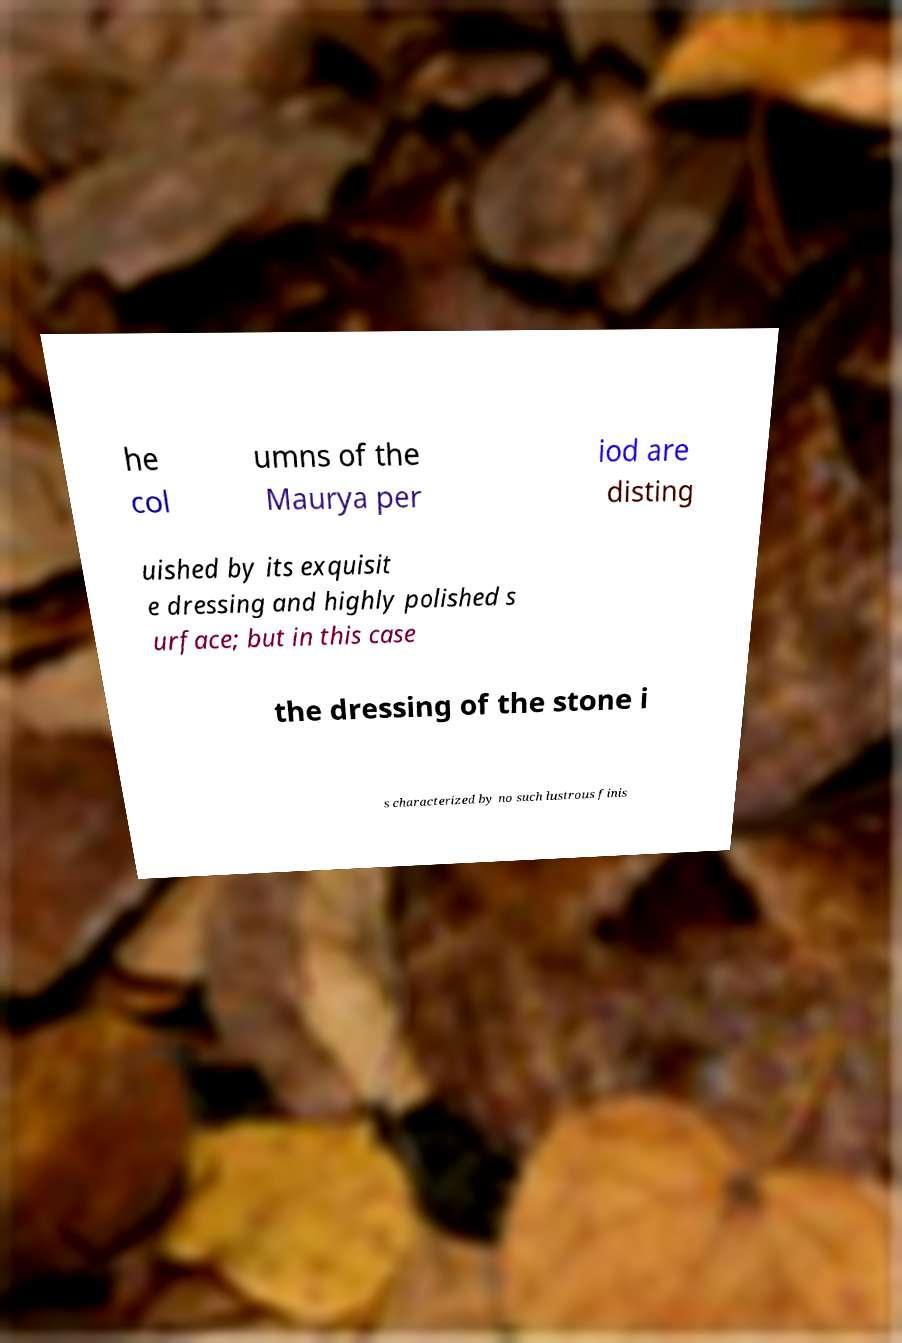What messages or text are displayed in this image? I need them in a readable, typed format. he col umns of the Maurya per iod are disting uished by its exquisit e dressing and highly polished s urface; but in this case the dressing of the stone i s characterized by no such lustrous finis 